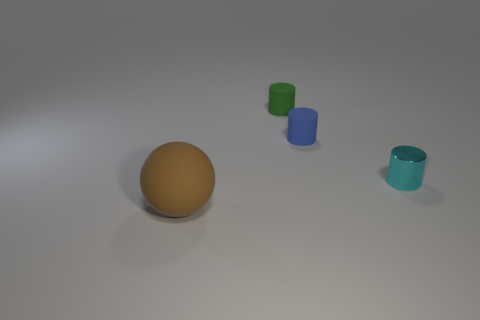What number of objects are both to the right of the tiny blue rubber cylinder and left of the green matte thing?
Make the answer very short. 0. Do the object in front of the cyan shiny cylinder and the cylinder to the right of the small blue cylinder have the same size?
Your response must be concise. No. What number of things are tiny matte objects right of the green matte thing or tiny cyan metallic objects?
Provide a short and direct response. 2. There is a small cyan cylinder that is to the right of the tiny green matte cylinder; what is its material?
Ensure brevity in your answer.  Metal. What material is the cyan cylinder?
Provide a succinct answer. Metal. There is a object to the left of the small rubber object behind the tiny matte cylinder that is in front of the tiny green rubber cylinder; what is it made of?
Your answer should be very brief. Rubber. Is there any other thing that is the same material as the tiny cyan cylinder?
Your response must be concise. No. Do the matte ball and the rubber cylinder behind the tiny blue object have the same size?
Offer a terse response. No. How many objects are either things that are on the left side of the small blue cylinder or rubber objects that are behind the brown rubber sphere?
Your answer should be very brief. 3. The matte thing that is to the left of the green cylinder is what color?
Your response must be concise. Brown. 